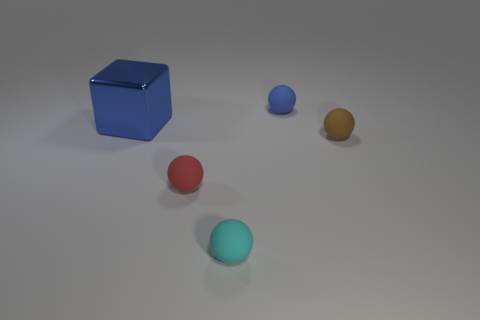Add 3 small brown metallic spheres. How many objects exist? 8 Subtract 1 balls. How many balls are left? 3 Subtract all yellow balls. Subtract all red blocks. How many balls are left? 4 Subtract all balls. How many objects are left? 1 Add 3 tiny red rubber objects. How many tiny red rubber objects are left? 4 Add 2 large red cylinders. How many large red cylinders exist? 2 Subtract 1 red spheres. How many objects are left? 4 Subtract all tiny red matte objects. Subtract all large cyan cubes. How many objects are left? 4 